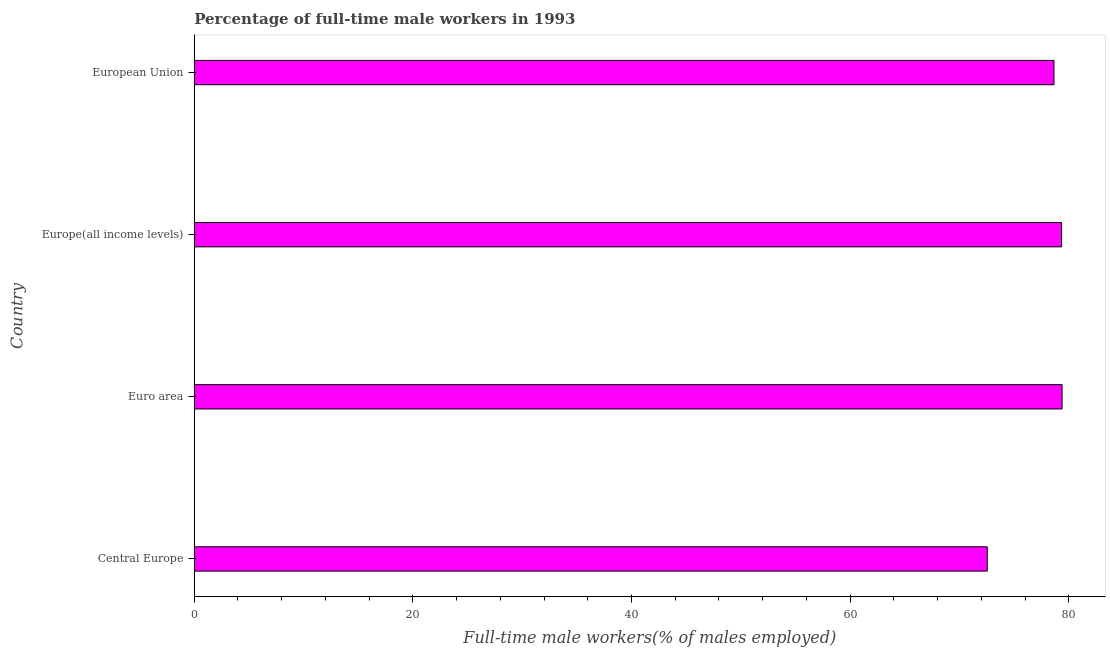Does the graph contain any zero values?
Make the answer very short. No. What is the title of the graph?
Your response must be concise. Percentage of full-time male workers in 1993. What is the label or title of the X-axis?
Provide a succinct answer. Full-time male workers(% of males employed). What is the percentage of full-time male workers in Europe(all income levels)?
Offer a terse response. 79.34. Across all countries, what is the maximum percentage of full-time male workers?
Provide a succinct answer. 79.39. Across all countries, what is the minimum percentage of full-time male workers?
Keep it short and to the point. 72.54. In which country was the percentage of full-time male workers maximum?
Your answer should be compact. Euro area. In which country was the percentage of full-time male workers minimum?
Provide a succinct answer. Central Europe. What is the sum of the percentage of full-time male workers?
Offer a very short reply. 309.92. What is the difference between the percentage of full-time male workers in Europe(all income levels) and European Union?
Keep it short and to the point. 0.69. What is the average percentage of full-time male workers per country?
Offer a very short reply. 77.48. What is the median percentage of full-time male workers?
Keep it short and to the point. 78.99. What is the ratio of the percentage of full-time male workers in Euro area to that in European Union?
Make the answer very short. 1.01. Is the percentage of full-time male workers in Central Europe less than that in Euro area?
Keep it short and to the point. Yes. What is the difference between the highest and the second highest percentage of full-time male workers?
Give a very brief answer. 0.05. Is the sum of the percentage of full-time male workers in Euro area and European Union greater than the maximum percentage of full-time male workers across all countries?
Your answer should be compact. Yes. What is the difference between the highest and the lowest percentage of full-time male workers?
Your response must be concise. 6.85. In how many countries, is the percentage of full-time male workers greater than the average percentage of full-time male workers taken over all countries?
Provide a short and direct response. 3. Are all the bars in the graph horizontal?
Provide a succinct answer. Yes. How many countries are there in the graph?
Your answer should be very brief. 4. Are the values on the major ticks of X-axis written in scientific E-notation?
Provide a succinct answer. No. What is the Full-time male workers(% of males employed) in Central Europe?
Ensure brevity in your answer.  72.54. What is the Full-time male workers(% of males employed) in Euro area?
Make the answer very short. 79.39. What is the Full-time male workers(% of males employed) in Europe(all income levels)?
Make the answer very short. 79.34. What is the Full-time male workers(% of males employed) in European Union?
Provide a succinct answer. 78.65. What is the difference between the Full-time male workers(% of males employed) in Central Europe and Euro area?
Make the answer very short. -6.85. What is the difference between the Full-time male workers(% of males employed) in Central Europe and Europe(all income levels)?
Offer a very short reply. -6.8. What is the difference between the Full-time male workers(% of males employed) in Central Europe and European Union?
Your response must be concise. -6.1. What is the difference between the Full-time male workers(% of males employed) in Euro area and Europe(all income levels)?
Your response must be concise. 0.05. What is the difference between the Full-time male workers(% of males employed) in Euro area and European Union?
Your answer should be compact. 0.74. What is the difference between the Full-time male workers(% of males employed) in Europe(all income levels) and European Union?
Offer a terse response. 0.69. What is the ratio of the Full-time male workers(% of males employed) in Central Europe to that in Euro area?
Make the answer very short. 0.91. What is the ratio of the Full-time male workers(% of males employed) in Central Europe to that in Europe(all income levels)?
Your answer should be compact. 0.91. What is the ratio of the Full-time male workers(% of males employed) in Central Europe to that in European Union?
Offer a very short reply. 0.92. What is the ratio of the Full-time male workers(% of males employed) in Euro area to that in Europe(all income levels)?
Ensure brevity in your answer.  1. What is the ratio of the Full-time male workers(% of males employed) in Euro area to that in European Union?
Offer a terse response. 1.01. What is the ratio of the Full-time male workers(% of males employed) in Europe(all income levels) to that in European Union?
Your answer should be compact. 1.01. 